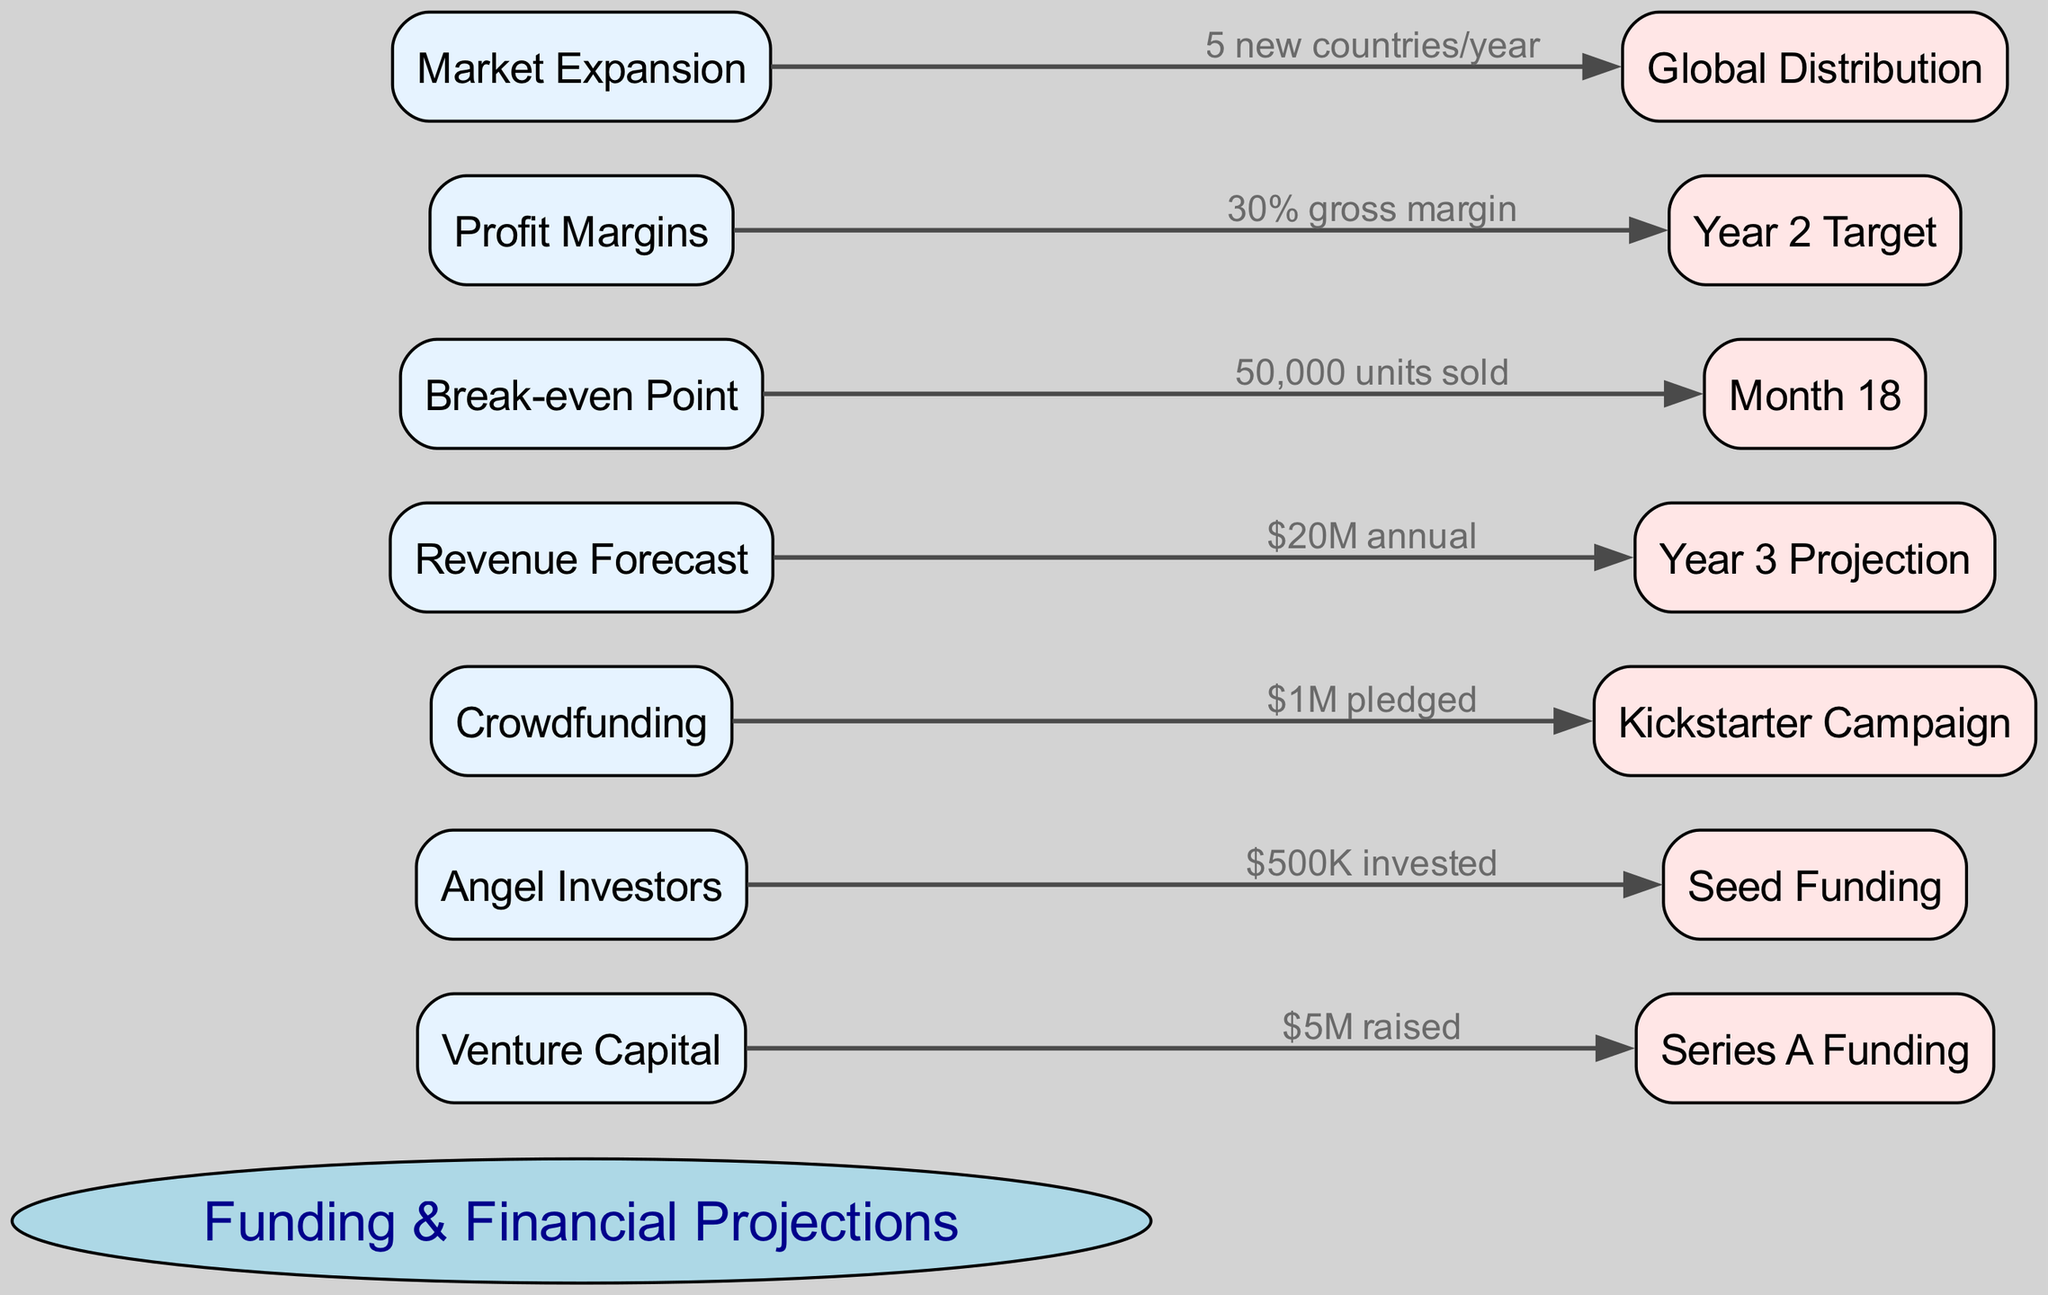What is the amount raised through Venture Capital? The diagram indicates that $5M was raised under the "Venture Capital" node, which is directly connected to "Series A Funding."
Answer: $5M How much did Angel Investors contribute? According to the connection labeled under "Angel Investors," it specifies that $500K was invested in "Seed Funding."
Answer: $500K What is the revenue forecast for Year 3? The "Revenue Forecast" node connects to "Year 3 Projection," showing an amount of $20M annual revenue projected.
Answer: $20M At what month does the startup reach the break-even point? The connection from "Break-even Point" leads to "Month 18," indicating that the break-even occurs at this time period after selling 50,000 units.
Answer: Month 18 What is the target profit margin for Year 2? The diagram specifies that the target profit margin under the "Profit Margins" node is a 30% gross margin by the end of Year 2.
Answer: 30% gross margin How many new countries will the startup expand into each year? The connection from "Market Expansion" to "Global Distribution" points out that the startup plans to expand into five new countries each year.
Answer: 5 new countries/year What is the total number of nodes in the diagram? By counting all nodes defined in the diagram, including the central concept, there are a total of 7 nodes in the structure.
Answer: 7 What is the relationship between Break-even Point and units sold? The "Break-even Point" node states that 50,000 units sold are required to reach this specific financial milestone, indicating a direct relationship between unit sales and break-even status.
Answer: 50,000 units sold What funding method involves a Kickstarter Campaign? The diagram clearly connects "Crowdfunding" to "Kickstarter Campaign," highlighting that this method actively involves the campaign for funding.
Answer: Kickstarter Campaign 